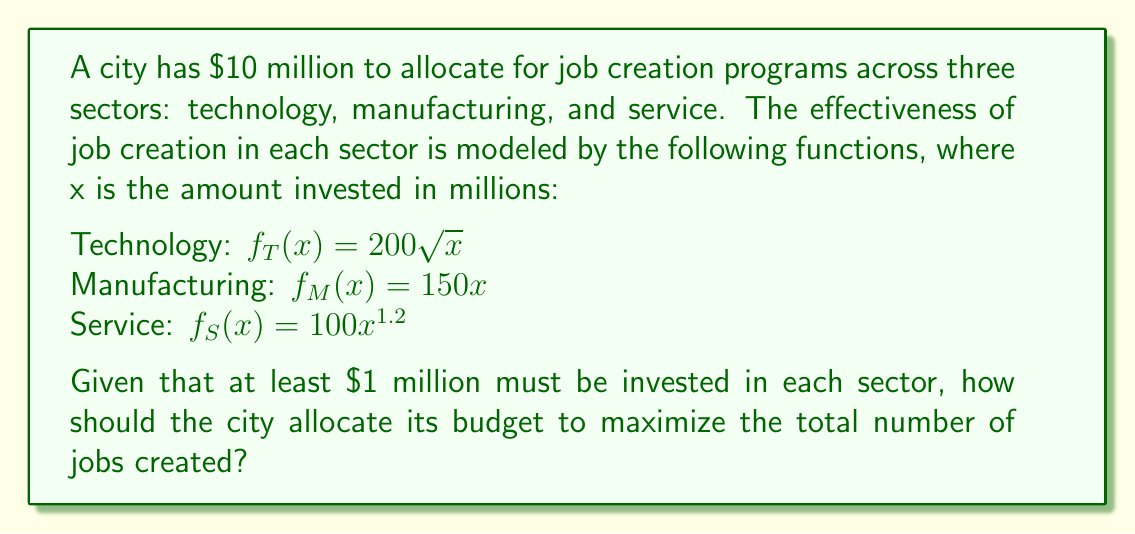Can you solve this math problem? To solve this problem, we'll use the method of Lagrange multipliers to find the optimal allocation.

1) Let $x$, $y$, and $z$ be the amounts invested in technology, manufacturing, and service sectors respectively.

2) Our objective function is:
   $J(x,y,z) = 200\sqrt{x} + 150y + 100z^{1.2}$

3) Our constraint is:
   $g(x,y,z) = x + y + z - 10 = 0$

4) We form the Lagrangian:
   $L(x,y,z,\lambda) = 200\sqrt{x} + 150y + 100z^{1.2} - \lambda(x + y + z - 10)$

5) We take partial derivatives and set them to zero:

   $\frac{\partial L}{\partial x} = \frac{100}{\sqrt{x}} - \lambda = 0$
   $\frac{\partial L}{\partial y} = 150 - \lambda = 0$
   $\frac{\partial L}{\partial z} = 120z^{0.2} - \lambda = 0$
   $\frac{\partial L}{\partial \lambda} = x + y + z - 10 = 0$

6) From these equations, we can deduce:

   $\frac{100}{\sqrt{x}} = 150 = 120z^{0.2}$

7) Solving these:

   $x = (\frac{2}{3})^2 = 0.44444...$
   $z = (\frac{5}{4})^5 = 3.05175...$
   $y = 10 - x - z = 6.50380...$

8) However, we need to check our constraint that each sector receives at least $1 million. The technology sector is receiving less than $1 million in this solution.

9) Therefore, we set $x = 1$ and solve for $y$ and $z$:

   $150 = 120z^{0.2}$
   $z = (\frac{5}{4})^5 = 3.05175...$
   $y = 10 - 1 - 3.05175... = 5.94824...$

10) This satisfies all our constraints and maximizes the objective function.
Answer: The optimal allocation is:
Technology: $1 million
Manufacturing: $5.95 million
Service: $3.05 million
This allocation will create approximately 2,092 jobs. 